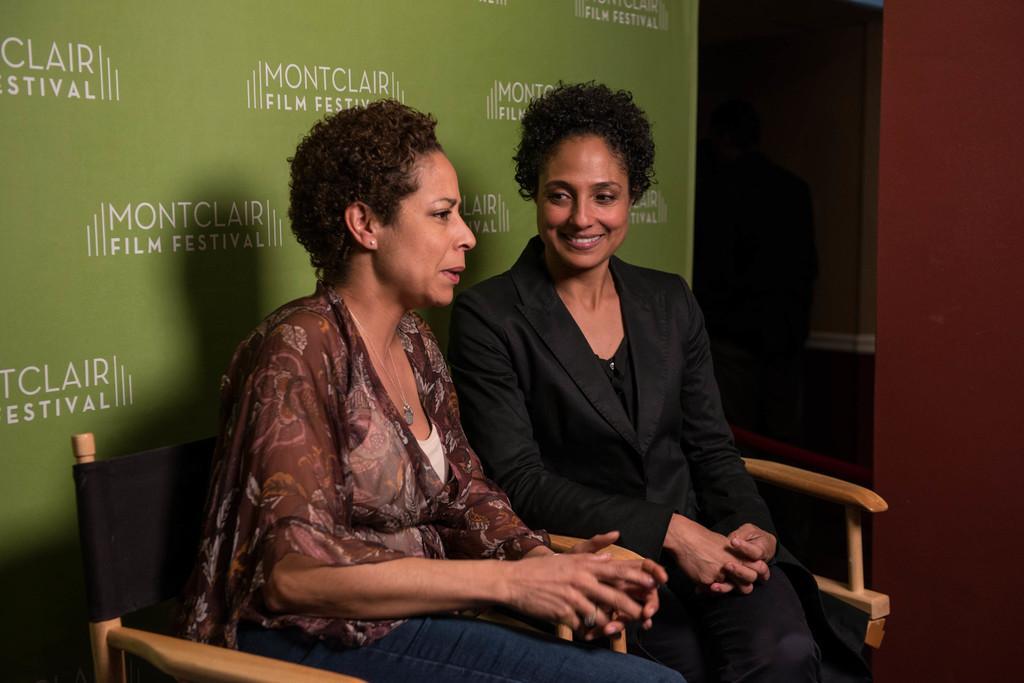Could you give a brief overview of what you see in this image? In this image at front there are two women sitting on the chairs. On the backside there is a wall. 